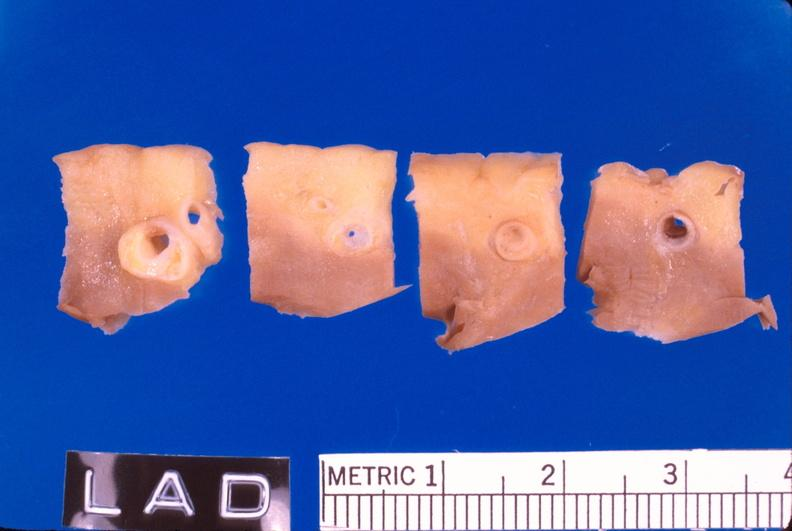what does this image show?
Answer the question using a single word or phrase. Coronary artery atherosclerosis 